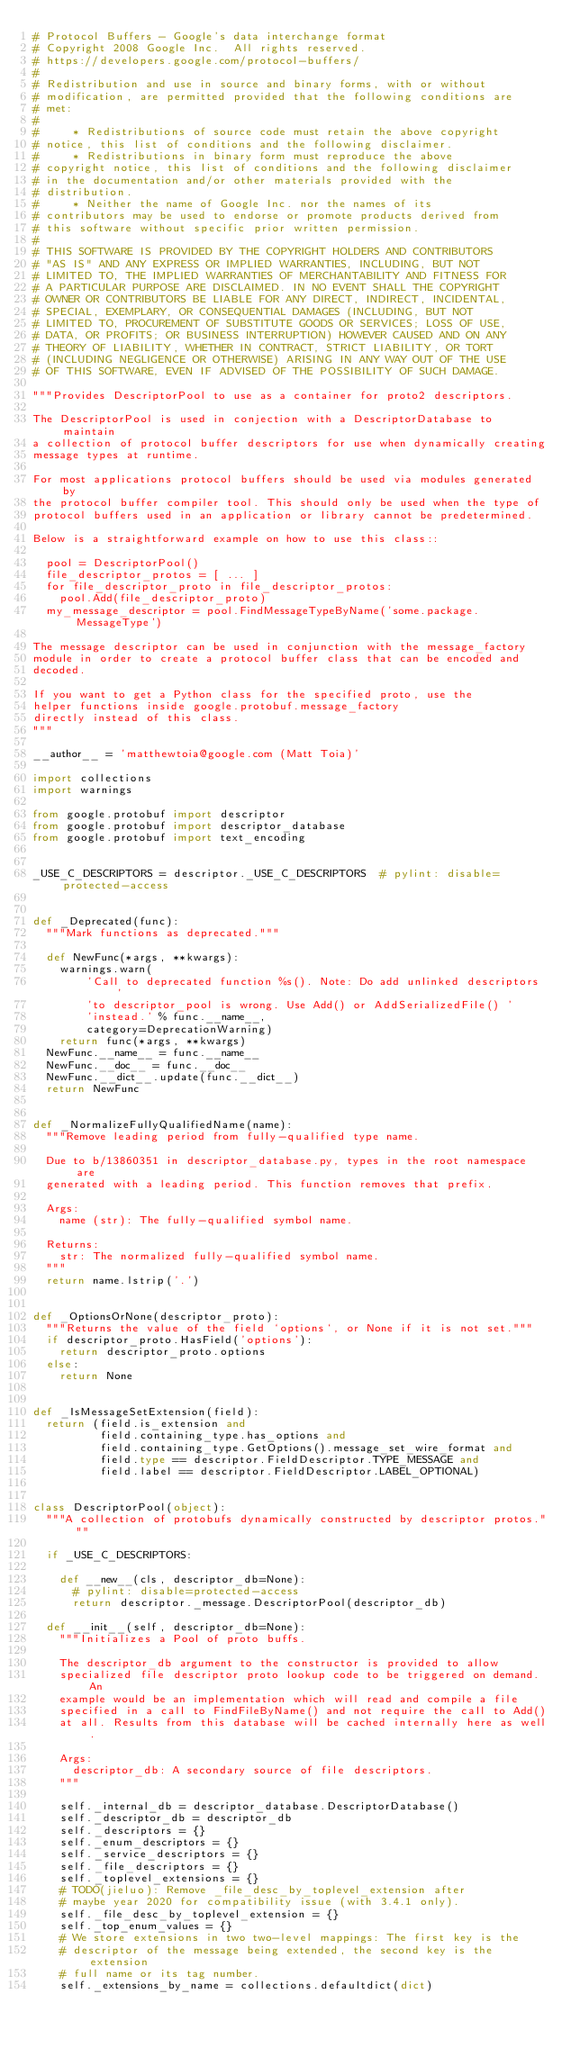<code> <loc_0><loc_0><loc_500><loc_500><_Python_># Protocol Buffers - Google's data interchange format
# Copyright 2008 Google Inc.  All rights reserved.
# https://developers.google.com/protocol-buffers/
#
# Redistribution and use in source and binary forms, with or without
# modification, are permitted provided that the following conditions are
# met:
#
#     * Redistributions of source code must retain the above copyright
# notice, this list of conditions and the following disclaimer.
#     * Redistributions in binary form must reproduce the above
# copyright notice, this list of conditions and the following disclaimer
# in the documentation and/or other materials provided with the
# distribution.
#     * Neither the name of Google Inc. nor the names of its
# contributors may be used to endorse or promote products derived from
# this software without specific prior written permission.
#
# THIS SOFTWARE IS PROVIDED BY THE COPYRIGHT HOLDERS AND CONTRIBUTORS
# "AS IS" AND ANY EXPRESS OR IMPLIED WARRANTIES, INCLUDING, BUT NOT
# LIMITED TO, THE IMPLIED WARRANTIES OF MERCHANTABILITY AND FITNESS FOR
# A PARTICULAR PURPOSE ARE DISCLAIMED. IN NO EVENT SHALL THE COPYRIGHT
# OWNER OR CONTRIBUTORS BE LIABLE FOR ANY DIRECT, INDIRECT, INCIDENTAL,
# SPECIAL, EXEMPLARY, OR CONSEQUENTIAL DAMAGES (INCLUDING, BUT NOT
# LIMITED TO, PROCUREMENT OF SUBSTITUTE GOODS OR SERVICES; LOSS OF USE,
# DATA, OR PROFITS; OR BUSINESS INTERRUPTION) HOWEVER CAUSED AND ON ANY
# THEORY OF LIABILITY, WHETHER IN CONTRACT, STRICT LIABILITY, OR TORT
# (INCLUDING NEGLIGENCE OR OTHERWISE) ARISING IN ANY WAY OUT OF THE USE
# OF THIS SOFTWARE, EVEN IF ADVISED OF THE POSSIBILITY OF SUCH DAMAGE.

"""Provides DescriptorPool to use as a container for proto2 descriptors.

The DescriptorPool is used in conjection with a DescriptorDatabase to maintain
a collection of protocol buffer descriptors for use when dynamically creating
message types at runtime.

For most applications protocol buffers should be used via modules generated by
the protocol buffer compiler tool. This should only be used when the type of
protocol buffers used in an application or library cannot be predetermined.

Below is a straightforward example on how to use this class::

  pool = DescriptorPool()
  file_descriptor_protos = [ ... ]
  for file_descriptor_proto in file_descriptor_protos:
    pool.Add(file_descriptor_proto)
  my_message_descriptor = pool.FindMessageTypeByName('some.package.MessageType')

The message descriptor can be used in conjunction with the message_factory
module in order to create a protocol buffer class that can be encoded and
decoded.

If you want to get a Python class for the specified proto, use the
helper functions inside google.protobuf.message_factory
directly instead of this class.
"""

__author__ = 'matthewtoia@google.com (Matt Toia)'

import collections
import warnings

from google.protobuf import descriptor
from google.protobuf import descriptor_database
from google.protobuf import text_encoding


_USE_C_DESCRIPTORS = descriptor._USE_C_DESCRIPTORS  # pylint: disable=protected-access


def _Deprecated(func):
  """Mark functions as deprecated."""

  def NewFunc(*args, **kwargs):
    warnings.warn(
        'Call to deprecated function %s(). Note: Do add unlinked descriptors '
        'to descriptor_pool is wrong. Use Add() or AddSerializedFile() '
        'instead.' % func.__name__,
        category=DeprecationWarning)
    return func(*args, **kwargs)
  NewFunc.__name__ = func.__name__
  NewFunc.__doc__ = func.__doc__
  NewFunc.__dict__.update(func.__dict__)
  return NewFunc


def _NormalizeFullyQualifiedName(name):
  """Remove leading period from fully-qualified type name.

  Due to b/13860351 in descriptor_database.py, types in the root namespace are
  generated with a leading period. This function removes that prefix.

  Args:
    name (str): The fully-qualified symbol name.

  Returns:
    str: The normalized fully-qualified symbol name.
  """
  return name.lstrip('.')


def _OptionsOrNone(descriptor_proto):
  """Returns the value of the field `options`, or None if it is not set."""
  if descriptor_proto.HasField('options'):
    return descriptor_proto.options
  else:
    return None


def _IsMessageSetExtension(field):
  return (field.is_extension and
          field.containing_type.has_options and
          field.containing_type.GetOptions().message_set_wire_format and
          field.type == descriptor.FieldDescriptor.TYPE_MESSAGE and
          field.label == descriptor.FieldDescriptor.LABEL_OPTIONAL)


class DescriptorPool(object):
  """A collection of protobufs dynamically constructed by descriptor protos."""

  if _USE_C_DESCRIPTORS:

    def __new__(cls, descriptor_db=None):
      # pylint: disable=protected-access
      return descriptor._message.DescriptorPool(descriptor_db)

  def __init__(self, descriptor_db=None):
    """Initializes a Pool of proto buffs.

    The descriptor_db argument to the constructor is provided to allow
    specialized file descriptor proto lookup code to be triggered on demand. An
    example would be an implementation which will read and compile a file
    specified in a call to FindFileByName() and not require the call to Add()
    at all. Results from this database will be cached internally here as well.

    Args:
      descriptor_db: A secondary source of file descriptors.
    """

    self._internal_db = descriptor_database.DescriptorDatabase()
    self._descriptor_db = descriptor_db
    self._descriptors = {}
    self._enum_descriptors = {}
    self._service_descriptors = {}
    self._file_descriptors = {}
    self._toplevel_extensions = {}
    # TODO(jieluo): Remove _file_desc_by_toplevel_extension after
    # maybe year 2020 for compatibility issue (with 3.4.1 only).
    self._file_desc_by_toplevel_extension = {}
    self._top_enum_values = {}
    # We store extensions in two two-level mappings: The first key is the
    # descriptor of the message being extended, the second key is the extension
    # full name or its tag number.
    self._extensions_by_name = collections.defaultdict(dict)</code> 